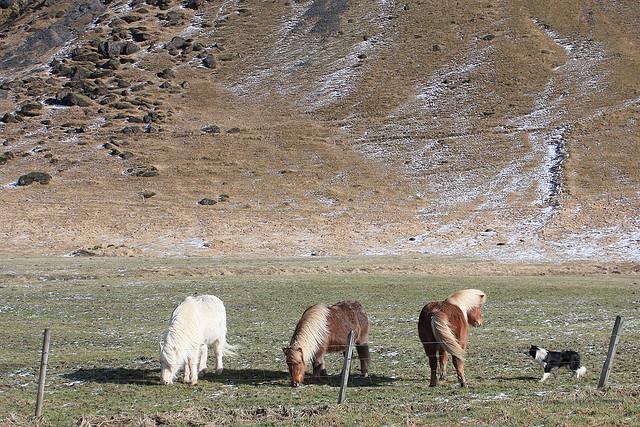How many horses?
Short answer required. 3. What is the breed of the dog?
Keep it brief. Collie. How many brown horses are there?
Answer briefly. 2. 